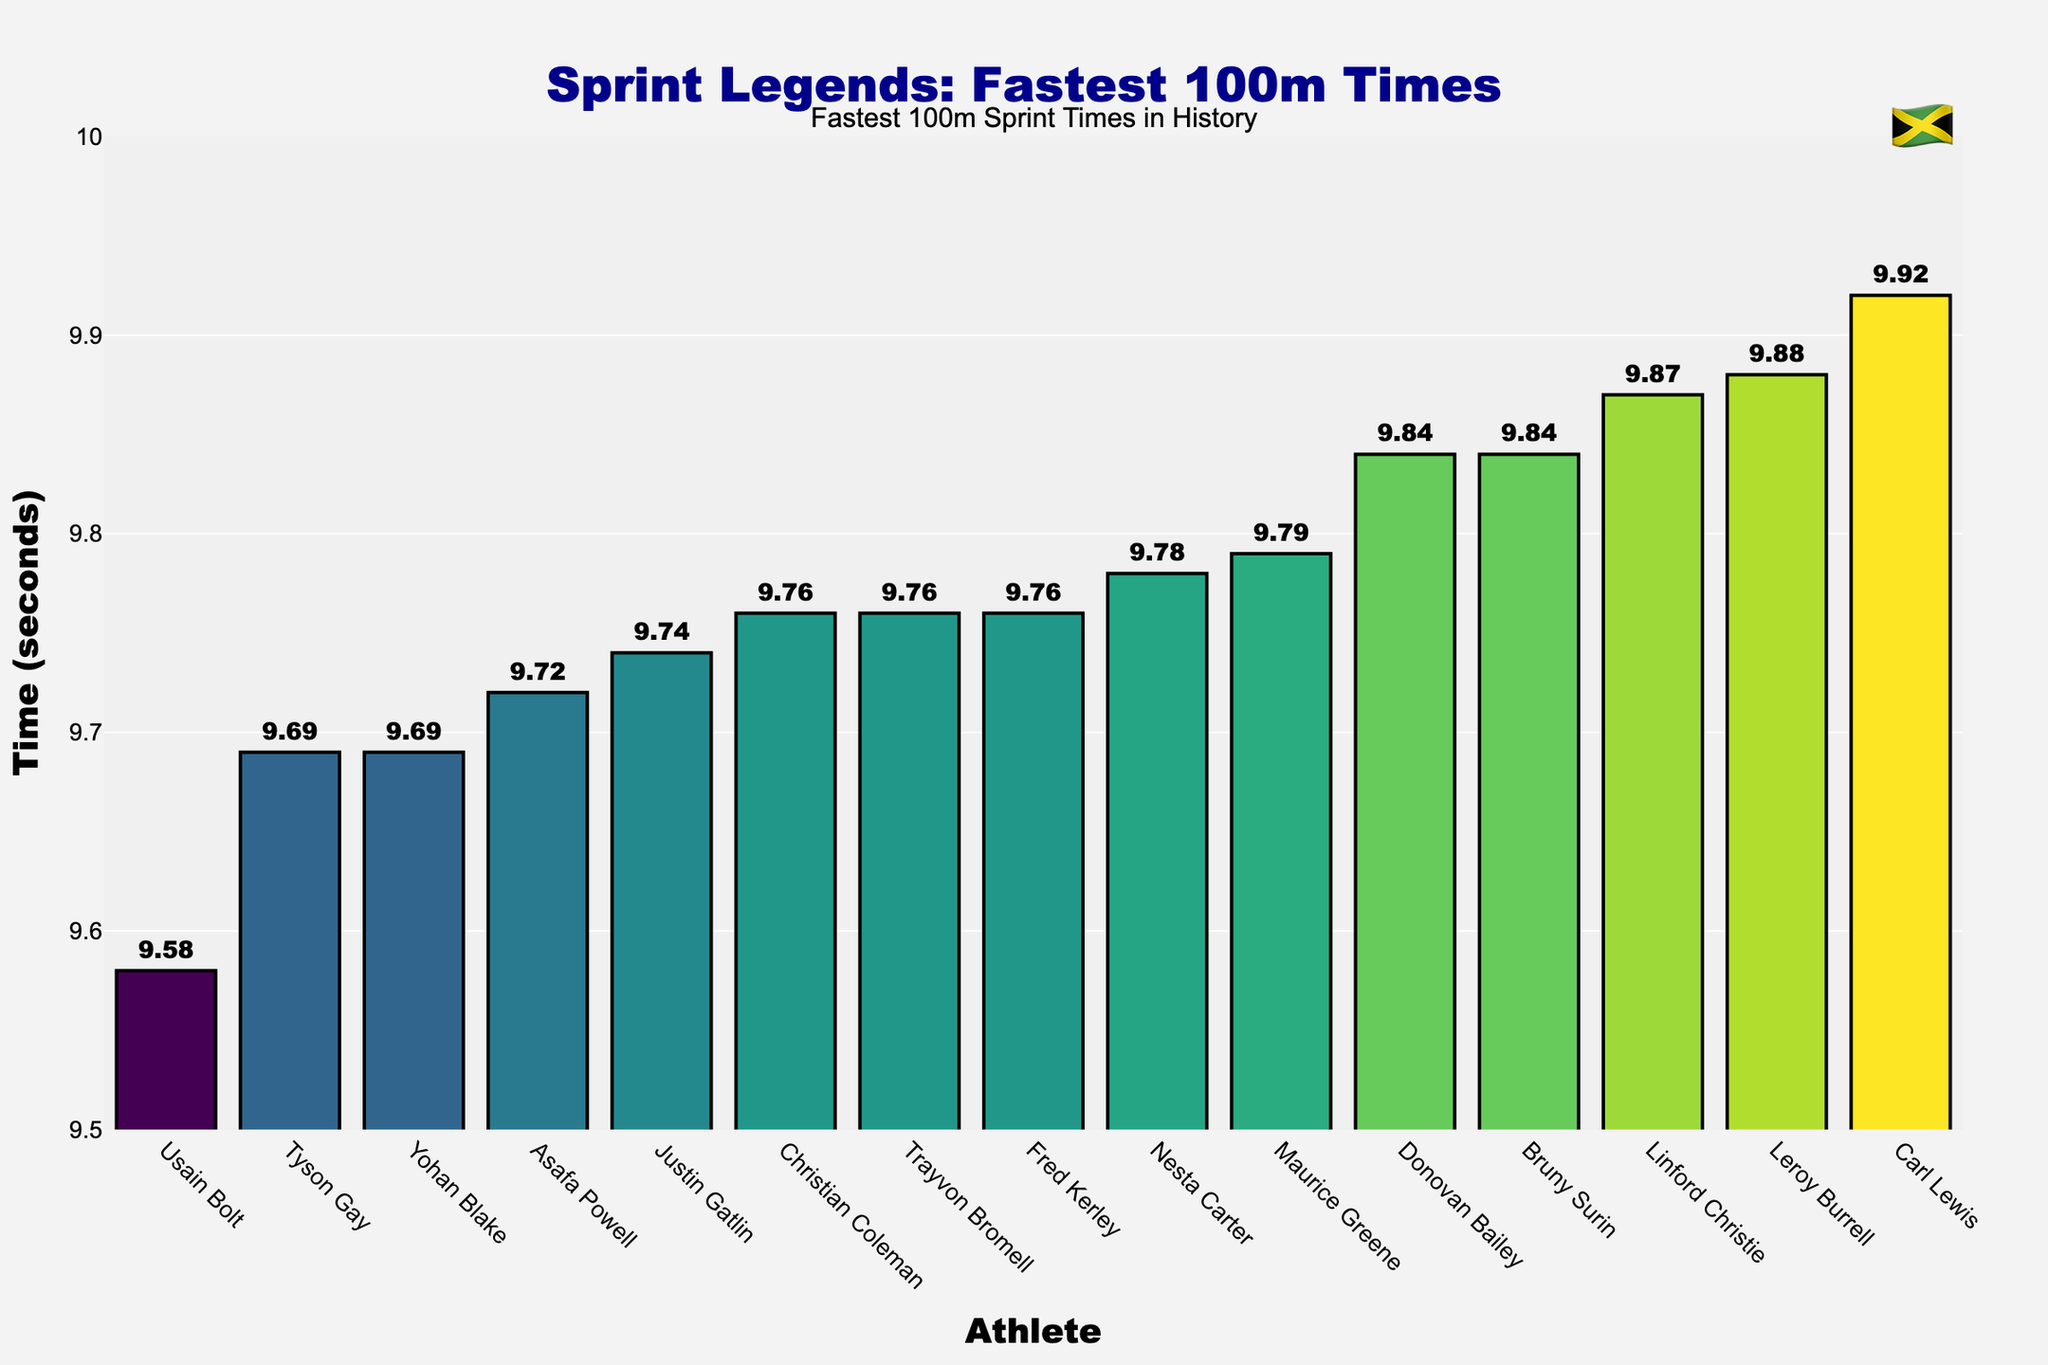How many athletes have sprint times below 9.8 seconds? We observe the sorted plot and count the number of bars representing sprint times less than 9.8. They are: Usain Bolt, Tyson Gay, Yohan Blake, Asafa Powell, Justin Gatlin, Christian Coleman, Trayvon Bromell, Fred Kerley, and Nesta Carter. Thus, there are 9 athletes.
Answer: 9 Which athlete has the fastest 100m sprint time and what is that time? We look for the shortest bar in the plot, which represents the fastest time. Usain Bolt has the fastest time, which is 9.58 seconds.
Answer: Usain Bolt, 9.58 seconds Who are the athletes that have the same sprint times of 9.69 seconds? By observing the plot, we find two bars of equal height representing the time of 9.69 seconds, associated with Tyson Gay and Yohan Blake.
Answer: Tyson Gay, Yohan Blake What is the difference between Usain Bolt’s and Justin Gatlin’s 100m sprint times? Locate Usain Bolt’s bar at 9.58 seconds and Justin Gatlin’s bar at 9.74 seconds. Subtract the two times: 9.74 - 9.58 equals 0.16 seconds.
Answer: 0.16 seconds What is the average sprint time of the top 5 fastest athletes? Identify the times of the top 5 athletes: Usain Bolt (9.58), Tyson Gay (9.69), Yohan Blake (9.69), Asafa Powell (9.72), and Justin Gatlin (9.74). Sum these times: 9.58 + 9.69 + 9.69 + 9.72 + 9.74 = 48.42 seconds. Then, divide by 5: 48.42 / 5 = 9.684 seconds.
Answer: 9.684 seconds Which athletes have sprint times between 9.8 and 9.9 seconds? Check the plot for bars representing times within the range 9.8 to 9.9 seconds. These athletes are Donovan Bailey (9.84) and Bruny Surin (9.84).
Answer: Donovan Bailey, Bruny Surin How many athletes have the exact same sprint time of 9.76 seconds? Look for bars of identical height representing 9.76 seconds. There are three such bars for Christian Coleman, Trayvon Bromell, and Fred Kerley.
Answer: 3 What is the median sprint time of all the athletes? List all times in ascending order: 9.58, 9.69, 9.69, 9.72, 9.74, 9.76, 9.76, 9.76, 9.78, 9.79, 9.84, 9.84, 9.87, 9.88, 9.92. Count the number of data points (15), the median is the 8th value, which is 9.76 seconds.
Answer: 9.76 seconds What is the difference in sprint times between the fastest and the slowest athlete in the plot? Determine the fastest (Usain Bolt at 9.58) and the slowest (Carl Lewis at 9.92). Calculate the difference: 9.92 - 9.58 = 0.34 seconds.
Answer: 0.34 seconds Which athlete is closest to Donovan Bailey in sprint time, and what is the time difference? Donovan Bailey’s time is 9.84 seconds. The closest is Bruny Surin, who also has a time of 9.84 seconds, making the time difference 0 seconds.
Answer: Bruny Surin, 0 seconds 